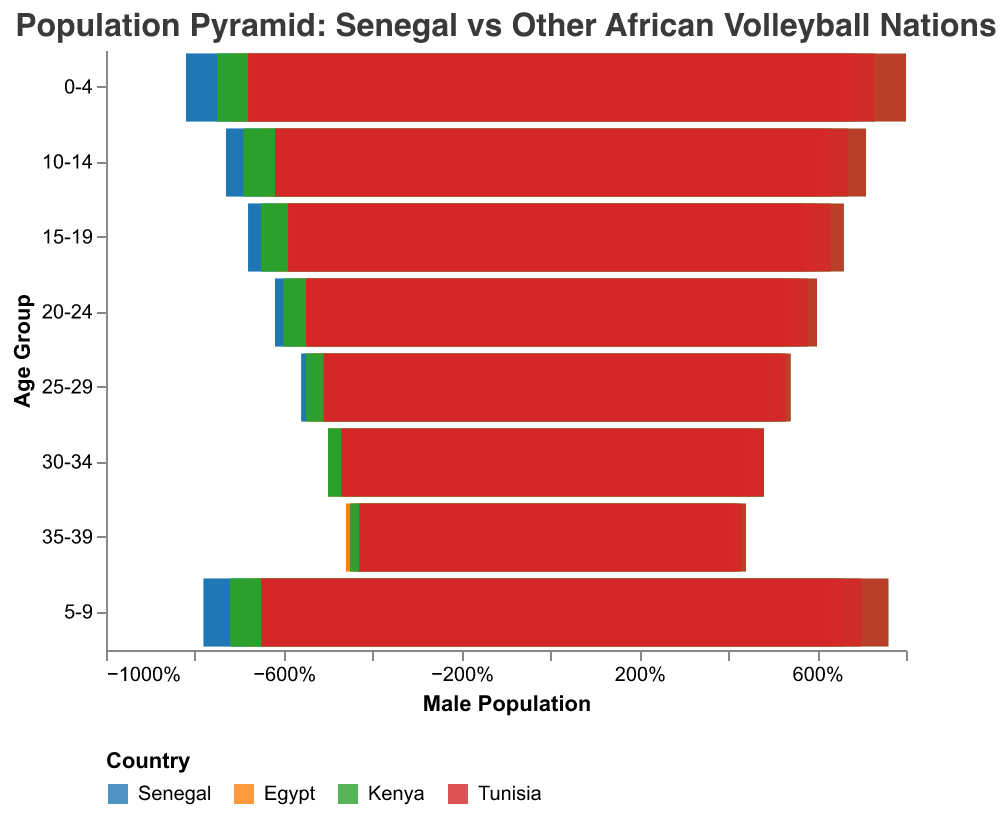What is the title of the population pyramid figure? The title is located at the top of the figure and reads "Population Pyramid: Senegal vs Other African Volleyball Nations."
Answer: "Population Pyramid: Senegal vs Other African Volleyball Nations" Which country has the highest percentage of the male population in the 0-4 age group? By observing the bars for the 0-4 age group, we can see which bar extends furthest to the left for males. The longest bar represents Senegal with a male percentage of 8.2.
Answer: Senegal How does the percentage of 10-14-year-old males in Tunisia compare to those in Egypt? Looking at the bars for the 10-14 age group, the male percentage for Tunisia is 6.2%, and for Egypt, it is 6.5%.
Answer: Tunisia has a lower percentage of 10-14-year-old males compared to Egypt Which country has the smallest gap between male and female populations in the 5-9 age group? By comparing the lengths of the male and female bars for the 5-9 age group across all countries, the difference in length is smallest for Egypt (6.8% male vs. 6.6% female).
Answer: Egypt What is the average percentage of 20-24-year-old females across all four countries? The percentages of females aged 20-24 for Senegal, Egypt, Kenya, and Tunisia are 6.0%, 5.6%, 5.8%, and 5.3% respectively. The sum of these values is 22.7%. Dividing by 4, we get the average as approximately 5.675%.
Answer: 5.675% Which age group has the highest overall combined male and female population percentage in Senegal? Summing the male and female percentages for each age group in Senegal, the 0-4 age group has the highest combined value of 16.2% (8.2 + 8.0).
Answer: 0-4 Is the female population percentage in Kenya for the age group 15-19 higher or lower than the same age group in Senegal? Looking at the bars for females aged 15-19, Kenya has a percentage of 6.3% while Senegal has 6.6%. Therefore, Kenya's is lower.
Answer: Lower How do the male percentages for age groups 25-29 compare between Kenya and Tunisia? For the 25-29 age group, Kenya's male percentage is 5.5%, and Tunisia's is 5.1%.
Answer: Kenya's percentage is higher What is the combined percentage of the 30-34-year-old population (male + female) in Egypt? The male percentage is 5.0% and the female percentage is 4.8% for Egypt in the 30-34 age group. Adding these, the combined percentage is 9.8%.
Answer: 9.8% Which country has a more balanced male-to-female ratio in the age group 35-39, Kenya or Tunisia? Comparing the bars for the 35-39 age group, Kenya has 4.5% males and 4.3% females (difference of 0.2), while Tunisia has 4.3% males and 4.1% females (difference of 0.2). Both countries have an equal balanced ratio for this age group.
Answer: Both are equally balanced 